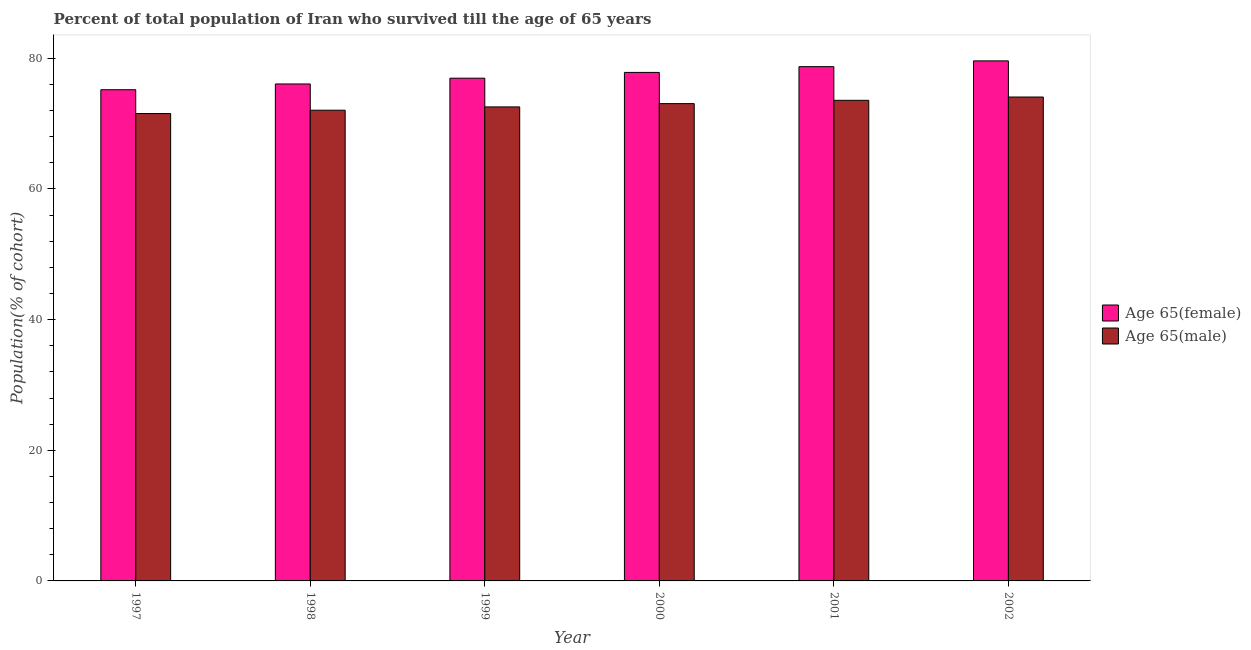Are the number of bars per tick equal to the number of legend labels?
Provide a succinct answer. Yes. How many bars are there on the 1st tick from the left?
Your answer should be very brief. 2. What is the label of the 6th group of bars from the left?
Offer a very short reply. 2002. In how many cases, is the number of bars for a given year not equal to the number of legend labels?
Give a very brief answer. 0. What is the percentage of female population who survived till age of 65 in 2002?
Keep it short and to the point. 79.61. Across all years, what is the maximum percentage of male population who survived till age of 65?
Your answer should be very brief. 74.08. Across all years, what is the minimum percentage of female population who survived till age of 65?
Keep it short and to the point. 75.2. What is the total percentage of female population who survived till age of 65 in the graph?
Offer a terse response. 464.43. What is the difference between the percentage of female population who survived till age of 65 in 1997 and that in 1998?
Your response must be concise. -0.88. What is the difference between the percentage of male population who survived till age of 65 in 2000 and the percentage of female population who survived till age of 65 in 2001?
Keep it short and to the point. -0.51. What is the average percentage of male population who survived till age of 65 per year?
Your answer should be very brief. 72.82. In how many years, is the percentage of female population who survived till age of 65 greater than 56 %?
Offer a very short reply. 6. What is the ratio of the percentage of male population who survived till age of 65 in 1999 to that in 2000?
Offer a very short reply. 0.99. Is the percentage of female population who survived till age of 65 in 2000 less than that in 2002?
Make the answer very short. Yes. What is the difference between the highest and the second highest percentage of female population who survived till age of 65?
Your answer should be very brief. 0.88. What is the difference between the highest and the lowest percentage of male population who survived till age of 65?
Your answer should be very brief. 2.53. In how many years, is the percentage of female population who survived till age of 65 greater than the average percentage of female population who survived till age of 65 taken over all years?
Offer a terse response. 3. What does the 1st bar from the left in 1998 represents?
Offer a very short reply. Age 65(female). What does the 2nd bar from the right in 1997 represents?
Your answer should be very brief. Age 65(female). How many bars are there?
Your response must be concise. 12. Are all the bars in the graph horizontal?
Give a very brief answer. No. How many years are there in the graph?
Ensure brevity in your answer.  6. What is the difference between two consecutive major ticks on the Y-axis?
Your response must be concise. 20. Does the graph contain any zero values?
Provide a short and direct response. No. Where does the legend appear in the graph?
Your response must be concise. Center right. What is the title of the graph?
Ensure brevity in your answer.  Percent of total population of Iran who survived till the age of 65 years. What is the label or title of the Y-axis?
Keep it short and to the point. Population(% of cohort). What is the Population(% of cohort) of Age 65(female) in 1997?
Provide a succinct answer. 75.2. What is the Population(% of cohort) of Age 65(male) in 1997?
Give a very brief answer. 71.55. What is the Population(% of cohort) of Age 65(female) in 1998?
Your answer should be very brief. 76.08. What is the Population(% of cohort) in Age 65(male) in 1998?
Your answer should be very brief. 72.06. What is the Population(% of cohort) of Age 65(female) in 1999?
Your response must be concise. 76.96. What is the Population(% of cohort) in Age 65(male) in 1999?
Offer a terse response. 72.57. What is the Population(% of cohort) of Age 65(female) in 2000?
Your response must be concise. 77.85. What is the Population(% of cohort) of Age 65(male) in 2000?
Your answer should be very brief. 73.07. What is the Population(% of cohort) in Age 65(female) in 2001?
Make the answer very short. 78.73. What is the Population(% of cohort) in Age 65(male) in 2001?
Your answer should be compact. 73.58. What is the Population(% of cohort) of Age 65(female) in 2002?
Your answer should be very brief. 79.61. What is the Population(% of cohort) in Age 65(male) in 2002?
Provide a succinct answer. 74.08. Across all years, what is the maximum Population(% of cohort) in Age 65(female)?
Make the answer very short. 79.61. Across all years, what is the maximum Population(% of cohort) of Age 65(male)?
Your answer should be compact. 74.08. Across all years, what is the minimum Population(% of cohort) in Age 65(female)?
Provide a succinct answer. 75.2. Across all years, what is the minimum Population(% of cohort) in Age 65(male)?
Provide a succinct answer. 71.55. What is the total Population(% of cohort) of Age 65(female) in the graph?
Offer a very short reply. 464.43. What is the total Population(% of cohort) in Age 65(male) in the graph?
Make the answer very short. 436.91. What is the difference between the Population(% of cohort) of Age 65(female) in 1997 and that in 1998?
Make the answer very short. -0.88. What is the difference between the Population(% of cohort) of Age 65(male) in 1997 and that in 1998?
Offer a terse response. -0.51. What is the difference between the Population(% of cohort) in Age 65(female) in 1997 and that in 1999?
Provide a short and direct response. -1.77. What is the difference between the Population(% of cohort) in Age 65(male) in 1997 and that in 1999?
Your response must be concise. -1.01. What is the difference between the Population(% of cohort) in Age 65(female) in 1997 and that in 2000?
Offer a terse response. -2.65. What is the difference between the Population(% of cohort) in Age 65(male) in 1997 and that in 2000?
Keep it short and to the point. -1.52. What is the difference between the Population(% of cohort) in Age 65(female) in 1997 and that in 2001?
Make the answer very short. -3.53. What is the difference between the Population(% of cohort) of Age 65(male) in 1997 and that in 2001?
Provide a succinct answer. -2.02. What is the difference between the Population(% of cohort) of Age 65(female) in 1997 and that in 2002?
Your response must be concise. -4.42. What is the difference between the Population(% of cohort) in Age 65(male) in 1997 and that in 2002?
Offer a very short reply. -2.53. What is the difference between the Population(% of cohort) in Age 65(female) in 1998 and that in 1999?
Ensure brevity in your answer.  -0.88. What is the difference between the Population(% of cohort) of Age 65(male) in 1998 and that in 1999?
Your response must be concise. -0.51. What is the difference between the Population(% of cohort) in Age 65(female) in 1998 and that in 2000?
Offer a terse response. -1.77. What is the difference between the Population(% of cohort) of Age 65(male) in 1998 and that in 2000?
Provide a succinct answer. -1.01. What is the difference between the Population(% of cohort) of Age 65(female) in 1998 and that in 2001?
Ensure brevity in your answer.  -2.65. What is the difference between the Population(% of cohort) in Age 65(male) in 1998 and that in 2001?
Provide a short and direct response. -1.52. What is the difference between the Population(% of cohort) in Age 65(female) in 1998 and that in 2002?
Provide a short and direct response. -3.53. What is the difference between the Population(% of cohort) in Age 65(male) in 1998 and that in 2002?
Your answer should be very brief. -2.02. What is the difference between the Population(% of cohort) in Age 65(female) in 1999 and that in 2000?
Offer a terse response. -0.88. What is the difference between the Population(% of cohort) in Age 65(male) in 1999 and that in 2000?
Your answer should be very brief. -0.51. What is the difference between the Population(% of cohort) in Age 65(female) in 1999 and that in 2001?
Provide a succinct answer. -1.77. What is the difference between the Population(% of cohort) in Age 65(male) in 1999 and that in 2001?
Make the answer very short. -1.01. What is the difference between the Population(% of cohort) of Age 65(female) in 1999 and that in 2002?
Your response must be concise. -2.65. What is the difference between the Population(% of cohort) in Age 65(male) in 1999 and that in 2002?
Your answer should be compact. -1.52. What is the difference between the Population(% of cohort) in Age 65(female) in 2000 and that in 2001?
Offer a terse response. -0.88. What is the difference between the Population(% of cohort) in Age 65(male) in 2000 and that in 2001?
Your response must be concise. -0.51. What is the difference between the Population(% of cohort) in Age 65(female) in 2000 and that in 2002?
Make the answer very short. -1.77. What is the difference between the Population(% of cohort) in Age 65(male) in 2000 and that in 2002?
Make the answer very short. -1.01. What is the difference between the Population(% of cohort) in Age 65(female) in 2001 and that in 2002?
Ensure brevity in your answer.  -0.88. What is the difference between the Population(% of cohort) in Age 65(male) in 2001 and that in 2002?
Provide a succinct answer. -0.51. What is the difference between the Population(% of cohort) of Age 65(female) in 1997 and the Population(% of cohort) of Age 65(male) in 1998?
Provide a succinct answer. 3.14. What is the difference between the Population(% of cohort) in Age 65(female) in 1997 and the Population(% of cohort) in Age 65(male) in 1999?
Ensure brevity in your answer.  2.63. What is the difference between the Population(% of cohort) in Age 65(female) in 1997 and the Population(% of cohort) in Age 65(male) in 2000?
Offer a very short reply. 2.13. What is the difference between the Population(% of cohort) in Age 65(female) in 1997 and the Population(% of cohort) in Age 65(male) in 2001?
Offer a terse response. 1.62. What is the difference between the Population(% of cohort) of Age 65(female) in 1997 and the Population(% of cohort) of Age 65(male) in 2002?
Ensure brevity in your answer.  1.12. What is the difference between the Population(% of cohort) of Age 65(female) in 1998 and the Population(% of cohort) of Age 65(male) in 1999?
Keep it short and to the point. 3.51. What is the difference between the Population(% of cohort) of Age 65(female) in 1998 and the Population(% of cohort) of Age 65(male) in 2000?
Your answer should be compact. 3.01. What is the difference between the Population(% of cohort) in Age 65(female) in 1998 and the Population(% of cohort) in Age 65(male) in 2001?
Your answer should be compact. 2.5. What is the difference between the Population(% of cohort) of Age 65(female) in 1998 and the Population(% of cohort) of Age 65(male) in 2002?
Ensure brevity in your answer.  2. What is the difference between the Population(% of cohort) of Age 65(female) in 1999 and the Population(% of cohort) of Age 65(male) in 2000?
Offer a very short reply. 3.89. What is the difference between the Population(% of cohort) in Age 65(female) in 1999 and the Population(% of cohort) in Age 65(male) in 2001?
Keep it short and to the point. 3.39. What is the difference between the Population(% of cohort) in Age 65(female) in 1999 and the Population(% of cohort) in Age 65(male) in 2002?
Your answer should be compact. 2.88. What is the difference between the Population(% of cohort) of Age 65(female) in 2000 and the Population(% of cohort) of Age 65(male) in 2001?
Provide a short and direct response. 4.27. What is the difference between the Population(% of cohort) in Age 65(female) in 2000 and the Population(% of cohort) in Age 65(male) in 2002?
Provide a short and direct response. 3.77. What is the difference between the Population(% of cohort) of Age 65(female) in 2001 and the Population(% of cohort) of Age 65(male) in 2002?
Give a very brief answer. 4.65. What is the average Population(% of cohort) of Age 65(female) per year?
Offer a very short reply. 77.4. What is the average Population(% of cohort) of Age 65(male) per year?
Give a very brief answer. 72.82. In the year 1997, what is the difference between the Population(% of cohort) of Age 65(female) and Population(% of cohort) of Age 65(male)?
Your answer should be compact. 3.64. In the year 1998, what is the difference between the Population(% of cohort) in Age 65(female) and Population(% of cohort) in Age 65(male)?
Your response must be concise. 4.02. In the year 1999, what is the difference between the Population(% of cohort) of Age 65(female) and Population(% of cohort) of Age 65(male)?
Offer a terse response. 4.4. In the year 2000, what is the difference between the Population(% of cohort) in Age 65(female) and Population(% of cohort) in Age 65(male)?
Ensure brevity in your answer.  4.78. In the year 2001, what is the difference between the Population(% of cohort) in Age 65(female) and Population(% of cohort) in Age 65(male)?
Keep it short and to the point. 5.15. In the year 2002, what is the difference between the Population(% of cohort) in Age 65(female) and Population(% of cohort) in Age 65(male)?
Your response must be concise. 5.53. What is the ratio of the Population(% of cohort) of Age 65(female) in 1997 to that in 1998?
Ensure brevity in your answer.  0.99. What is the ratio of the Population(% of cohort) of Age 65(male) in 1997 to that in 1998?
Your response must be concise. 0.99. What is the ratio of the Population(% of cohort) in Age 65(female) in 1997 to that in 1999?
Provide a succinct answer. 0.98. What is the ratio of the Population(% of cohort) in Age 65(male) in 1997 to that in 1999?
Make the answer very short. 0.99. What is the ratio of the Population(% of cohort) of Age 65(female) in 1997 to that in 2000?
Your answer should be very brief. 0.97. What is the ratio of the Population(% of cohort) in Age 65(male) in 1997 to that in 2000?
Provide a succinct answer. 0.98. What is the ratio of the Population(% of cohort) in Age 65(female) in 1997 to that in 2001?
Your response must be concise. 0.96. What is the ratio of the Population(% of cohort) in Age 65(male) in 1997 to that in 2001?
Your answer should be compact. 0.97. What is the ratio of the Population(% of cohort) of Age 65(female) in 1997 to that in 2002?
Your answer should be very brief. 0.94. What is the ratio of the Population(% of cohort) of Age 65(male) in 1997 to that in 2002?
Ensure brevity in your answer.  0.97. What is the ratio of the Population(% of cohort) in Age 65(female) in 1998 to that in 1999?
Make the answer very short. 0.99. What is the ratio of the Population(% of cohort) of Age 65(male) in 1998 to that in 1999?
Provide a short and direct response. 0.99. What is the ratio of the Population(% of cohort) of Age 65(female) in 1998 to that in 2000?
Offer a very short reply. 0.98. What is the ratio of the Population(% of cohort) in Age 65(male) in 1998 to that in 2000?
Your response must be concise. 0.99. What is the ratio of the Population(% of cohort) of Age 65(female) in 1998 to that in 2001?
Offer a very short reply. 0.97. What is the ratio of the Population(% of cohort) of Age 65(male) in 1998 to that in 2001?
Ensure brevity in your answer.  0.98. What is the ratio of the Population(% of cohort) in Age 65(female) in 1998 to that in 2002?
Keep it short and to the point. 0.96. What is the ratio of the Population(% of cohort) of Age 65(male) in 1998 to that in 2002?
Keep it short and to the point. 0.97. What is the ratio of the Population(% of cohort) in Age 65(female) in 1999 to that in 2000?
Keep it short and to the point. 0.99. What is the ratio of the Population(% of cohort) of Age 65(male) in 1999 to that in 2000?
Make the answer very short. 0.99. What is the ratio of the Population(% of cohort) of Age 65(female) in 1999 to that in 2001?
Offer a very short reply. 0.98. What is the ratio of the Population(% of cohort) of Age 65(male) in 1999 to that in 2001?
Give a very brief answer. 0.99. What is the ratio of the Population(% of cohort) in Age 65(female) in 1999 to that in 2002?
Offer a very short reply. 0.97. What is the ratio of the Population(% of cohort) in Age 65(male) in 1999 to that in 2002?
Ensure brevity in your answer.  0.98. What is the ratio of the Population(% of cohort) of Age 65(male) in 2000 to that in 2001?
Your answer should be compact. 0.99. What is the ratio of the Population(% of cohort) of Age 65(female) in 2000 to that in 2002?
Your answer should be compact. 0.98. What is the ratio of the Population(% of cohort) in Age 65(male) in 2000 to that in 2002?
Your response must be concise. 0.99. What is the ratio of the Population(% of cohort) of Age 65(female) in 2001 to that in 2002?
Give a very brief answer. 0.99. What is the difference between the highest and the second highest Population(% of cohort) in Age 65(female)?
Offer a very short reply. 0.88. What is the difference between the highest and the second highest Population(% of cohort) in Age 65(male)?
Keep it short and to the point. 0.51. What is the difference between the highest and the lowest Population(% of cohort) of Age 65(female)?
Your answer should be very brief. 4.42. What is the difference between the highest and the lowest Population(% of cohort) in Age 65(male)?
Ensure brevity in your answer.  2.53. 